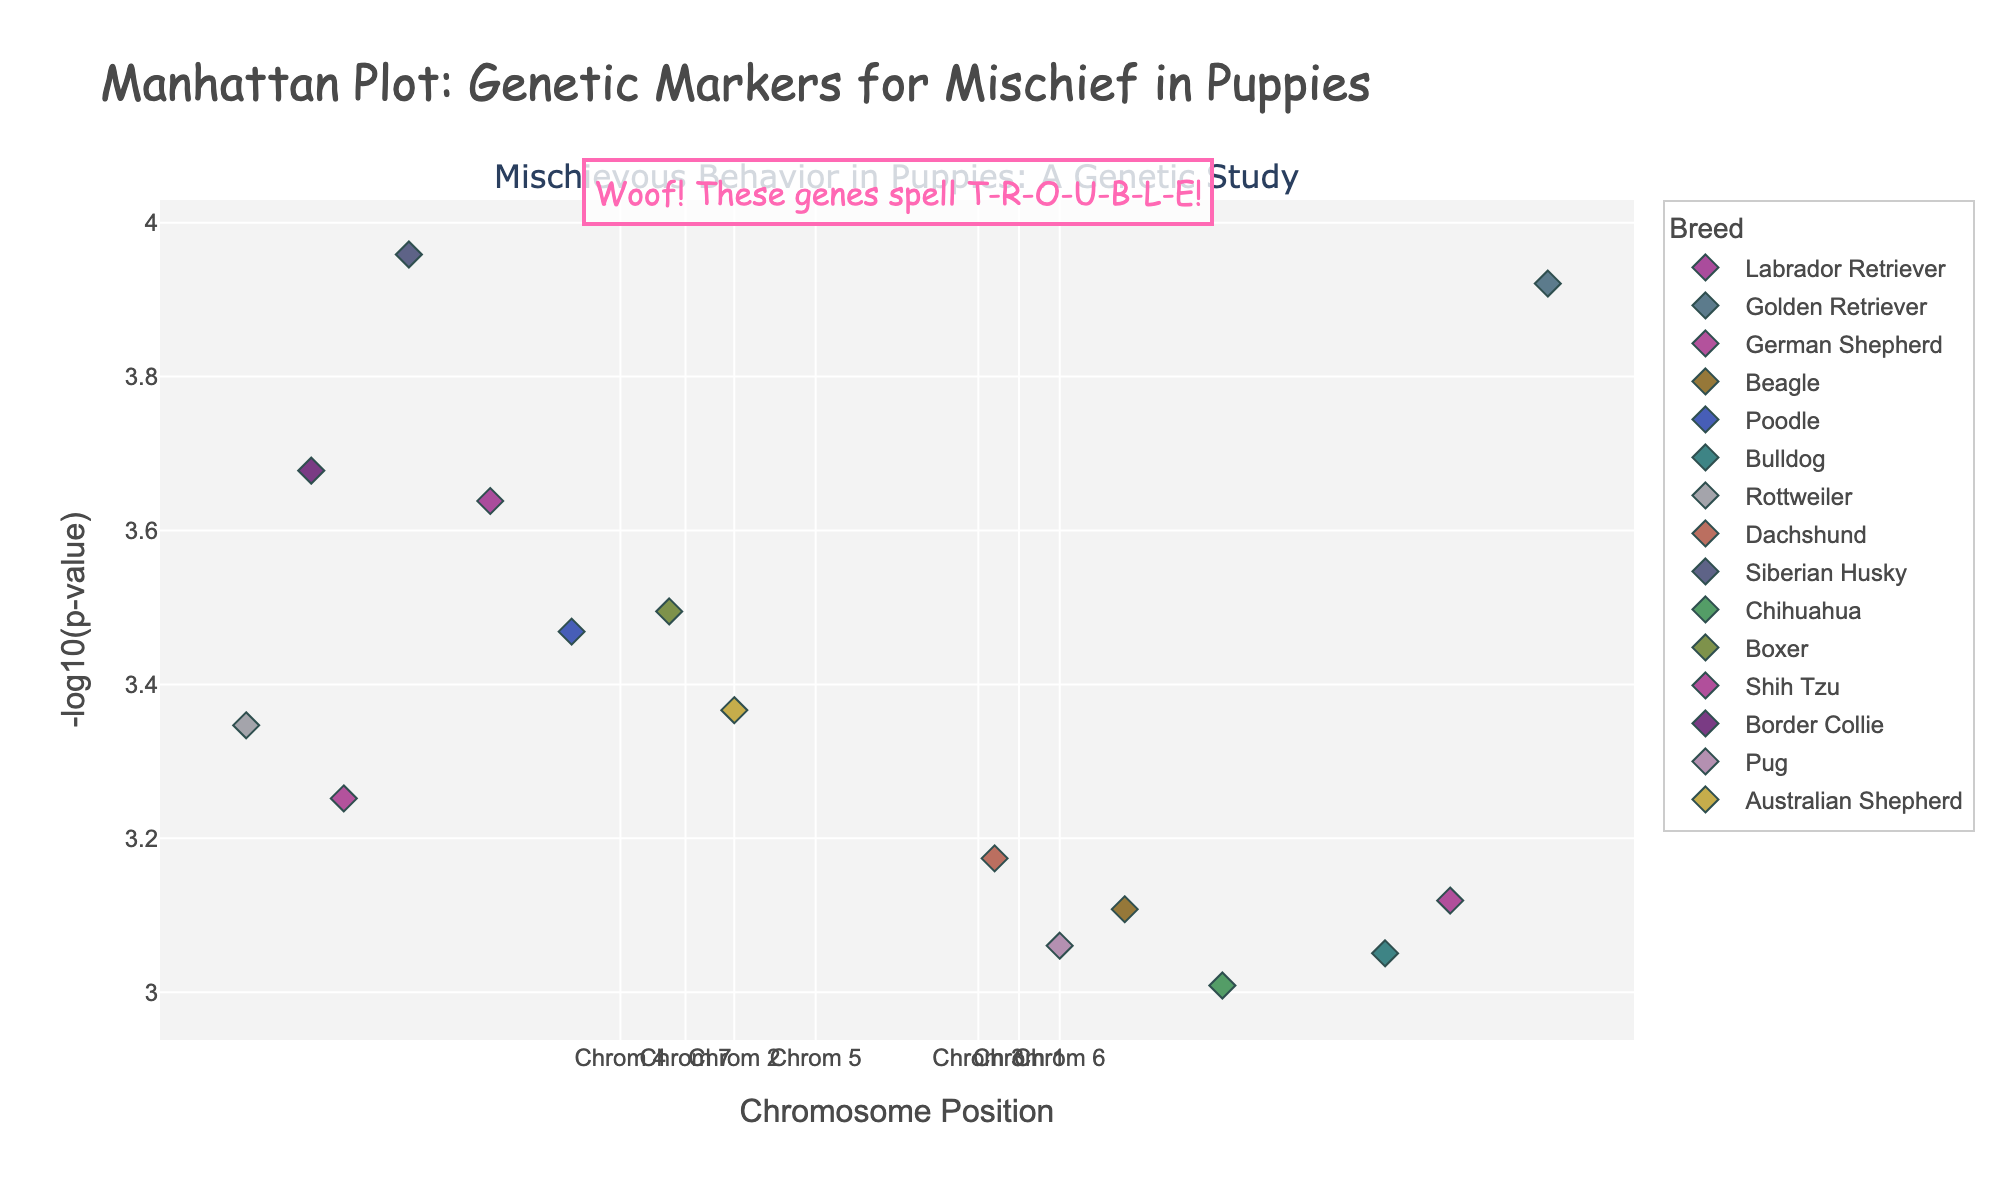What's the title of the plot? The title of the plot can be found towards the top of the figure. It is generally in larger fonts and a different style to stand out from the rest of the text.
Answer: Manhattan Plot: Genetic Markers for Mischief in Puppies What does the y-axis represent? The y-axis is labeled to indicate what it measures. In this plot, it shows -log10(p-value), which is a common measure in Manhattan plots to represent the significance of genetic markers.
Answer: -log10(p-value) Which breed has the data point with the lowest p-value? To find this, look for the data point that is highest on the y-axis (since -log10(p-value) means higher values are more significant). Hovering over points can give specific details.
Answer: Siberian Husky At what chromosome position does the Labrador Retriever's most significant marker occur? Find the Labrador Retriever's data points and then check the x-axis position of its highest point on the y-axis (most significant point).
Answer: 12,500,000 How many breeds have markers on chromosome 2? By identifying which breeds are listed under chromosome 2, we can count them. According to the data, the breeds are German Shepherd and Beagle.
Answer: 2 Which breed has the most significant marker on chromosome 7? Locate the markers on chromosome 7 and then identify which breed has the highest point along the y-axis for this chromosome.
Answer: Border Collie What's the average -log10(p-value) for breeds on chromosome 4? Calculate the -log10(p-value) for the breeds listed under chromosome 4, which are Rottweiler and Dachshund, and then find the average of these values.
Answer: -log10(0.00045) and -log10(0.00067) average is approximately 4.39 Compare the significance of the markers for Poodle and Boxer. Which one is greater? To compare, check the y-axis values for the Poodle and Boxer data points. The higher the point on the y-axis, the more significant the marker.
Answer: Poodle Which breed has the least significant marker overall? The least significant marker will have the lowest point on the y-axis. By looking at the bottom-most point on the y-axis and identifying its breed, we get the answer.
Answer: Chihuahua What's the median -log10(p-value) for all data points in the plot? To calculate the median, list out all the -log10(p-value) values, sort them, and find the middle value.
Answer: Approximately 4.34 